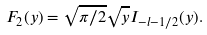<formula> <loc_0><loc_0><loc_500><loc_500>F _ { 2 } ( y ) = \sqrt { \pi / 2 } \sqrt { y } I _ { - l - 1 / 2 } ( y ) .</formula> 